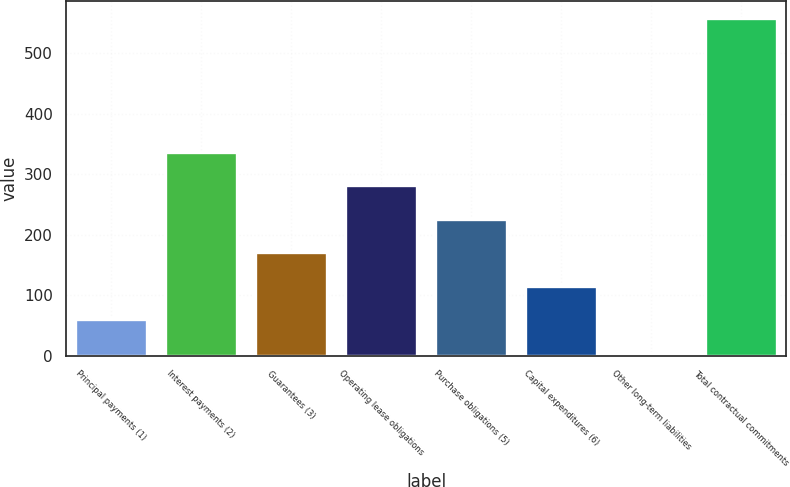<chart> <loc_0><loc_0><loc_500><loc_500><bar_chart><fcel>Principal payments (1)<fcel>Interest payments (2)<fcel>Guarantees (3)<fcel>Operating lease obligations<fcel>Purchase obligations (5)<fcel>Capital expenditures (6)<fcel>Other long-term liabilities<fcel>Total contractual commitments<nl><fcel>60.4<fcel>337.4<fcel>171.2<fcel>282<fcel>226.6<fcel>115.8<fcel>5<fcel>559<nl></chart> 